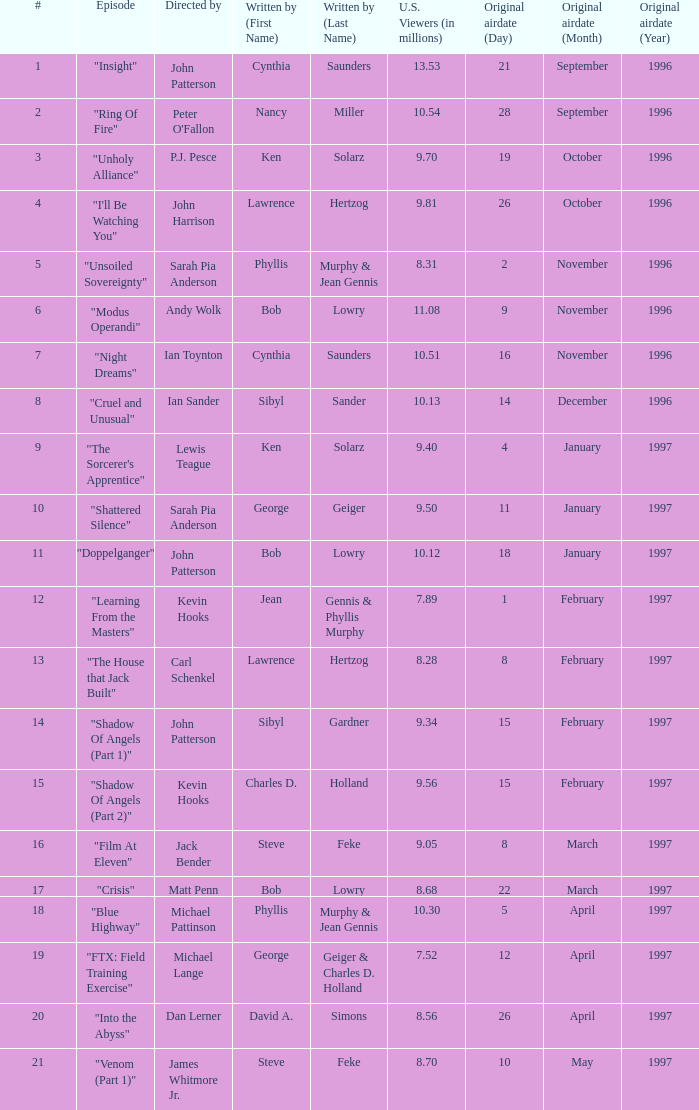Who wrote the episode with 7.52 million US viewers? George Geiger & Charles D. Holland. 